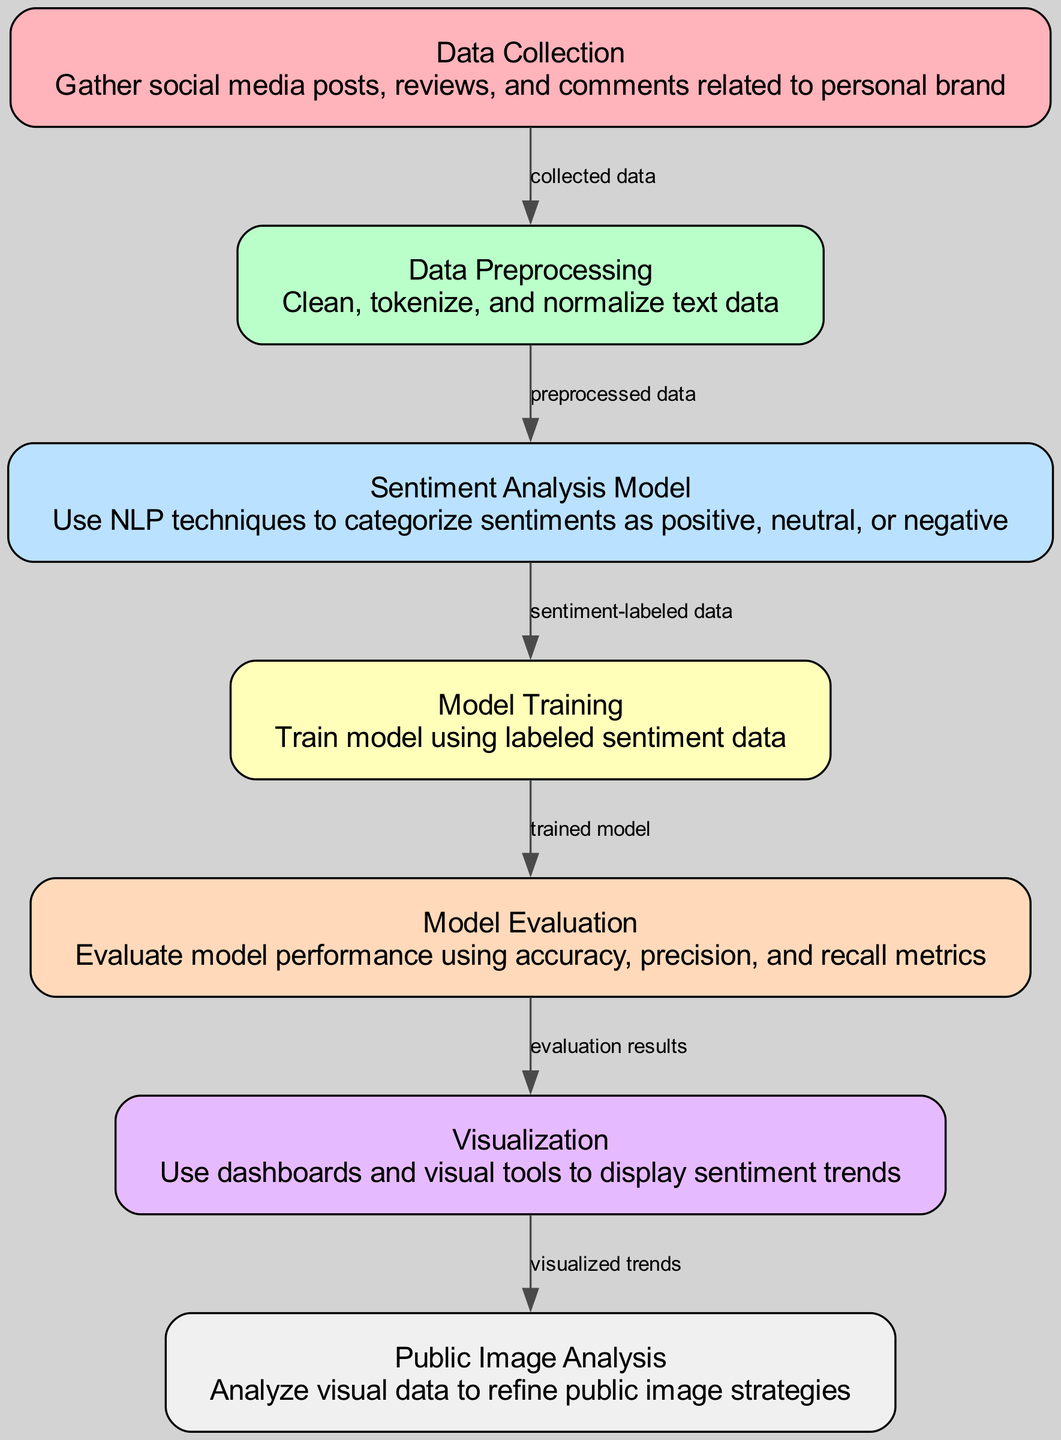What is the total number of nodes in the diagram? The diagram contains seven distinct nodes. By counting each labeled section, we find Data Collection, Data Preprocessing, Sentiment Analysis Model, Model Training, Model Evaluation, Visualization, and Public Image Analysis.
Answer: Seven Which node comes after Data Preprocessing? The arrow indicating flow shows that after Data Preprocessing, the next node is Sentiment Analysis Model. This is determined by following the directed edge from Data Preprocessing to Sentiment Analysis Model in the diagram.
Answer: Sentiment Analysis Model What is the last node in the diagram? The last node in the flow of the diagram is Public Image Analysis. This can be confirmed by tracing the connections from the previous nodes, clearly leading to this final step.
Answer: Public Image Analysis How many edges connect the nodes in total? By enumerating each directed connection in the diagram, there are a total of six edges that connect the nodes together. Each edge represents a flow of data or information between the respective nodes.
Answer: Six What metric is used to evaluate the model? In the Model Evaluation, specific metrics mentioned are accuracy, precision, and recall. These are standard metrics used to assess the performance of machine learning models.
Answer: Accuracy, precision, and recall What type of data is used for the Model Training? The data used for Model Training is referred to as sentiment-labeled data. This indicates that the data has been previously processed and categorized according to the sentiments identified in prior steps.
Answer: Sentiment-labeled data Which node's output is directed to Visualization? The output directed to Visualization comes from Model Evaluation. This step takes the evaluation results and provides them for visualization in a dashboard or other visual tool.
Answer: Model Evaluation What process occurs before model training? Prior to Model Training, the process that occurs is the Sentiment Analysis Model creation, which utilizes the sentiment-labeled data to train the model effectively.
Answer: Sentiment Analysis Model 